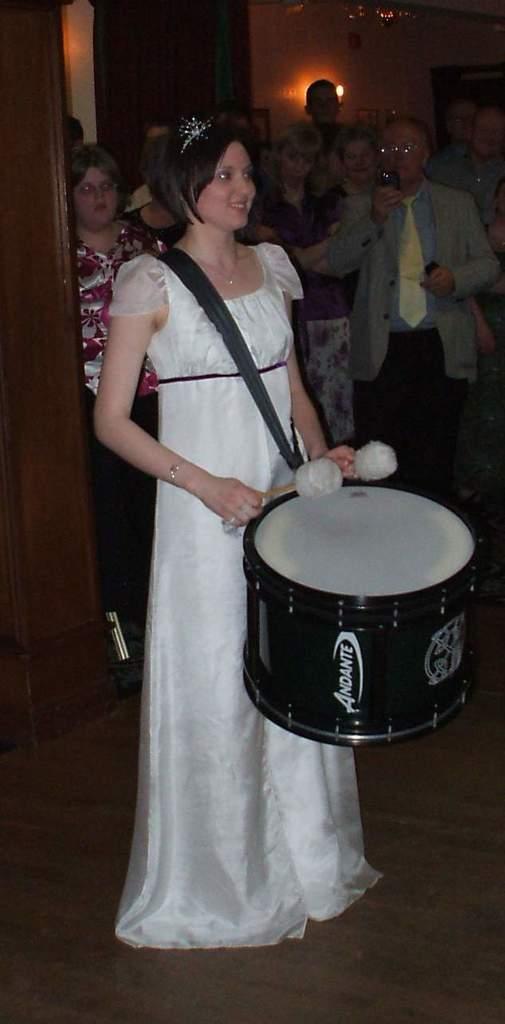How would you summarize this image in a sentence or two? In this picture we can see a woman standing, she has a drum with two drum sticks holding in the hands and in the backdrop there are few people standing, there is a pole on the left side and there is a wall in the background 